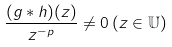<formula> <loc_0><loc_0><loc_500><loc_500>\frac { ( g \ast h ) ( z ) } { z ^ { - p } } \neq 0 \, ( z \in \mathbb { U } )</formula> 